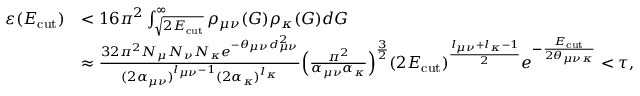Convert formula to latex. <formula><loc_0><loc_0><loc_500><loc_500>\begin{array} { r l } { \varepsilon ( E _ { c u t } ) } & { < 1 6 \pi ^ { 2 } \int _ { \sqrt { 2 E _ { c u t } } } ^ { \infty } \rho _ { \mu \nu } ( G ) \rho _ { \kappa } ( G ) d G } \\ & { \approx \frac { 3 2 \pi ^ { 2 } N _ { \mu } N _ { \nu } N _ { \kappa } e ^ { - \theta _ { \mu \nu } d _ { \mu \nu } ^ { 2 } } } { ( 2 \alpha _ { \mu \nu } ) ^ { l _ { \mu \nu } - 1 } ( 2 \alpha _ { \kappa } ) ^ { l _ { \kappa } } } \left ( \frac { \pi ^ { 2 } } { \alpha _ { \mu \nu } \alpha _ { \kappa } } \right ) ^ { \frac { 3 } { 2 } } ( 2 E _ { c u t } ) ^ { \frac { l _ { \mu \nu } + l _ { \kappa } - 1 } { 2 } } e ^ { - \frac { E _ { c u t } } { 2 \theta _ { \mu \nu \kappa } } } < \tau , } \end{array}</formula> 